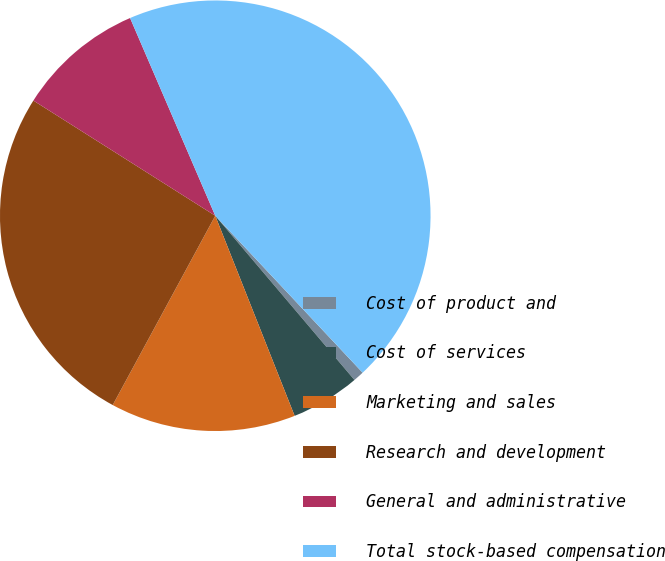<chart> <loc_0><loc_0><loc_500><loc_500><pie_chart><fcel>Cost of product and<fcel>Cost of services<fcel>Marketing and sales<fcel>Research and development<fcel>General and administrative<fcel>Total stock-based compensation<nl><fcel>0.81%<fcel>5.18%<fcel>13.91%<fcel>26.08%<fcel>9.54%<fcel>44.47%<nl></chart> 